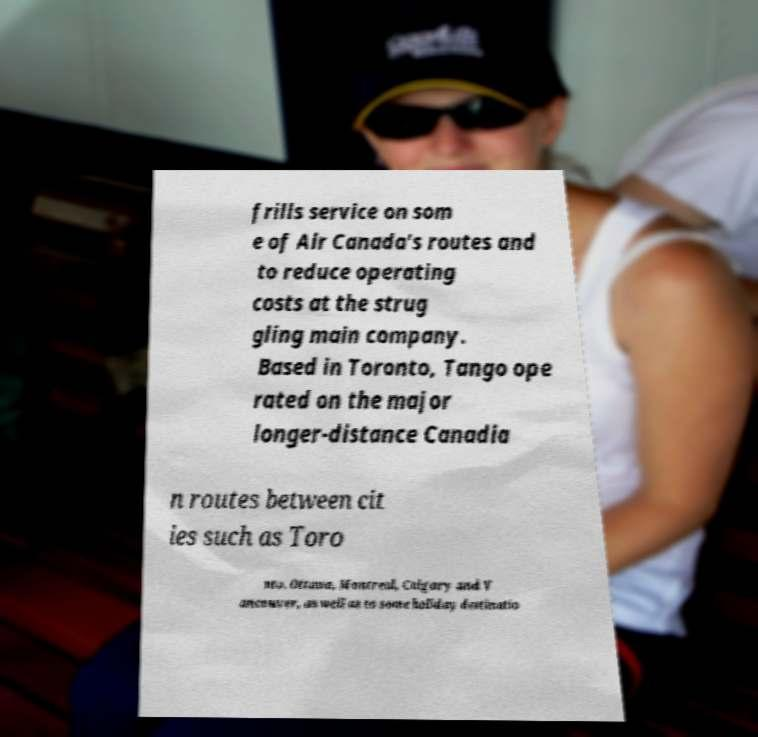What messages or text are displayed in this image? I need them in a readable, typed format. frills service on som e of Air Canada's routes and to reduce operating costs at the strug gling main company. Based in Toronto, Tango ope rated on the major longer-distance Canadia n routes between cit ies such as Toro nto, Ottawa, Montreal, Calgary and V ancouver, as well as to some holiday destinatio 